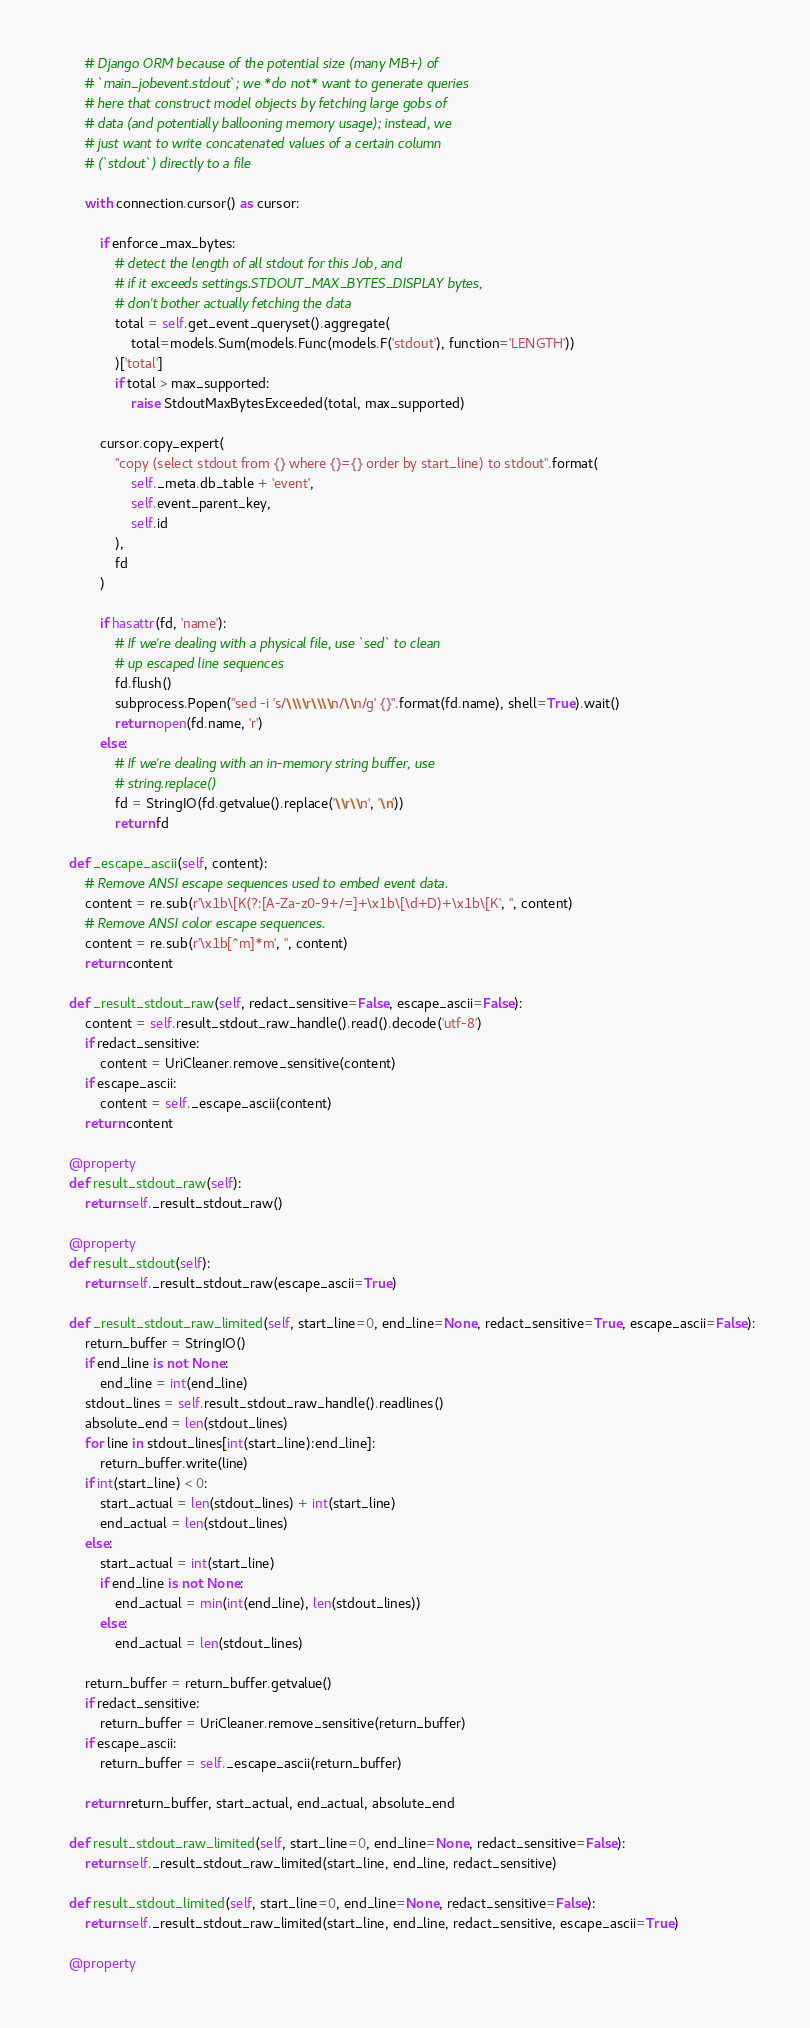Convert code to text. <code><loc_0><loc_0><loc_500><loc_500><_Python_>        # Django ORM because of the potential size (many MB+) of
        # `main_jobevent.stdout`; we *do not* want to generate queries
        # here that construct model objects by fetching large gobs of
        # data (and potentially ballooning memory usage); instead, we
        # just want to write concatenated values of a certain column
        # (`stdout`) directly to a file

        with connection.cursor() as cursor:

            if enforce_max_bytes:
                # detect the length of all stdout for this Job, and
                # if it exceeds settings.STDOUT_MAX_BYTES_DISPLAY bytes,
                # don't bother actually fetching the data
                total = self.get_event_queryset().aggregate(
                    total=models.Sum(models.Func(models.F('stdout'), function='LENGTH'))
                )['total']
                if total > max_supported:
                    raise StdoutMaxBytesExceeded(total, max_supported)

            cursor.copy_expert(
                "copy (select stdout from {} where {}={} order by start_line) to stdout".format(
                    self._meta.db_table + 'event',
                    self.event_parent_key,
                    self.id
                ),
                fd
            )

            if hasattr(fd, 'name'):
                # If we're dealing with a physical file, use `sed` to clean
                # up escaped line sequences
                fd.flush()
                subprocess.Popen("sed -i 's/\\\\r\\\\n/\\n/g' {}".format(fd.name), shell=True).wait()
                return open(fd.name, 'r')
            else:
                # If we're dealing with an in-memory string buffer, use
                # string.replace()
                fd = StringIO(fd.getvalue().replace('\\r\\n', '\n'))
                return fd

    def _escape_ascii(self, content):
        # Remove ANSI escape sequences used to embed event data.
        content = re.sub(r'\x1b\[K(?:[A-Za-z0-9+/=]+\x1b\[\d+D)+\x1b\[K', '', content)
        # Remove ANSI color escape sequences.
        content = re.sub(r'\x1b[^m]*m', '', content)
        return content

    def _result_stdout_raw(self, redact_sensitive=False, escape_ascii=False):
        content = self.result_stdout_raw_handle().read().decode('utf-8')
        if redact_sensitive:
            content = UriCleaner.remove_sensitive(content)
        if escape_ascii:
            content = self._escape_ascii(content)
        return content

    @property
    def result_stdout_raw(self):
        return self._result_stdout_raw()

    @property
    def result_stdout(self):
        return self._result_stdout_raw(escape_ascii=True)

    def _result_stdout_raw_limited(self, start_line=0, end_line=None, redact_sensitive=True, escape_ascii=False):
        return_buffer = StringIO()
        if end_line is not None:
            end_line = int(end_line)
        stdout_lines = self.result_stdout_raw_handle().readlines()
        absolute_end = len(stdout_lines)
        for line in stdout_lines[int(start_line):end_line]:
            return_buffer.write(line)
        if int(start_line) < 0:
            start_actual = len(stdout_lines) + int(start_line)
            end_actual = len(stdout_lines)
        else:
            start_actual = int(start_line)
            if end_line is not None:
                end_actual = min(int(end_line), len(stdout_lines))
            else:
                end_actual = len(stdout_lines)

        return_buffer = return_buffer.getvalue()
        if redact_sensitive:
            return_buffer = UriCleaner.remove_sensitive(return_buffer)
        if escape_ascii:
            return_buffer = self._escape_ascii(return_buffer)

        return return_buffer, start_actual, end_actual, absolute_end

    def result_stdout_raw_limited(self, start_line=0, end_line=None, redact_sensitive=False):
        return self._result_stdout_raw_limited(start_line, end_line, redact_sensitive)

    def result_stdout_limited(self, start_line=0, end_line=None, redact_sensitive=False):
        return self._result_stdout_raw_limited(start_line, end_line, redact_sensitive, escape_ascii=True)

    @property</code> 